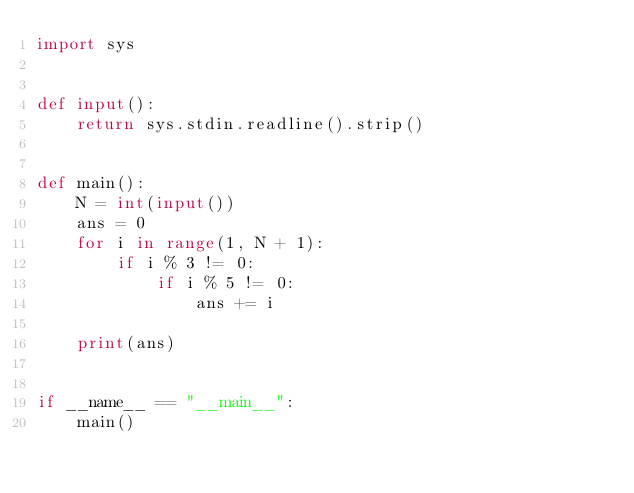Convert code to text. <code><loc_0><loc_0><loc_500><loc_500><_Python_>import sys


def input():
    return sys.stdin.readline().strip()


def main():
    N = int(input())
    ans = 0
    for i in range(1, N + 1):
        if i % 3 != 0:
            if i % 5 != 0:
                ans += i

    print(ans)


if __name__ == "__main__":
    main()
</code> 